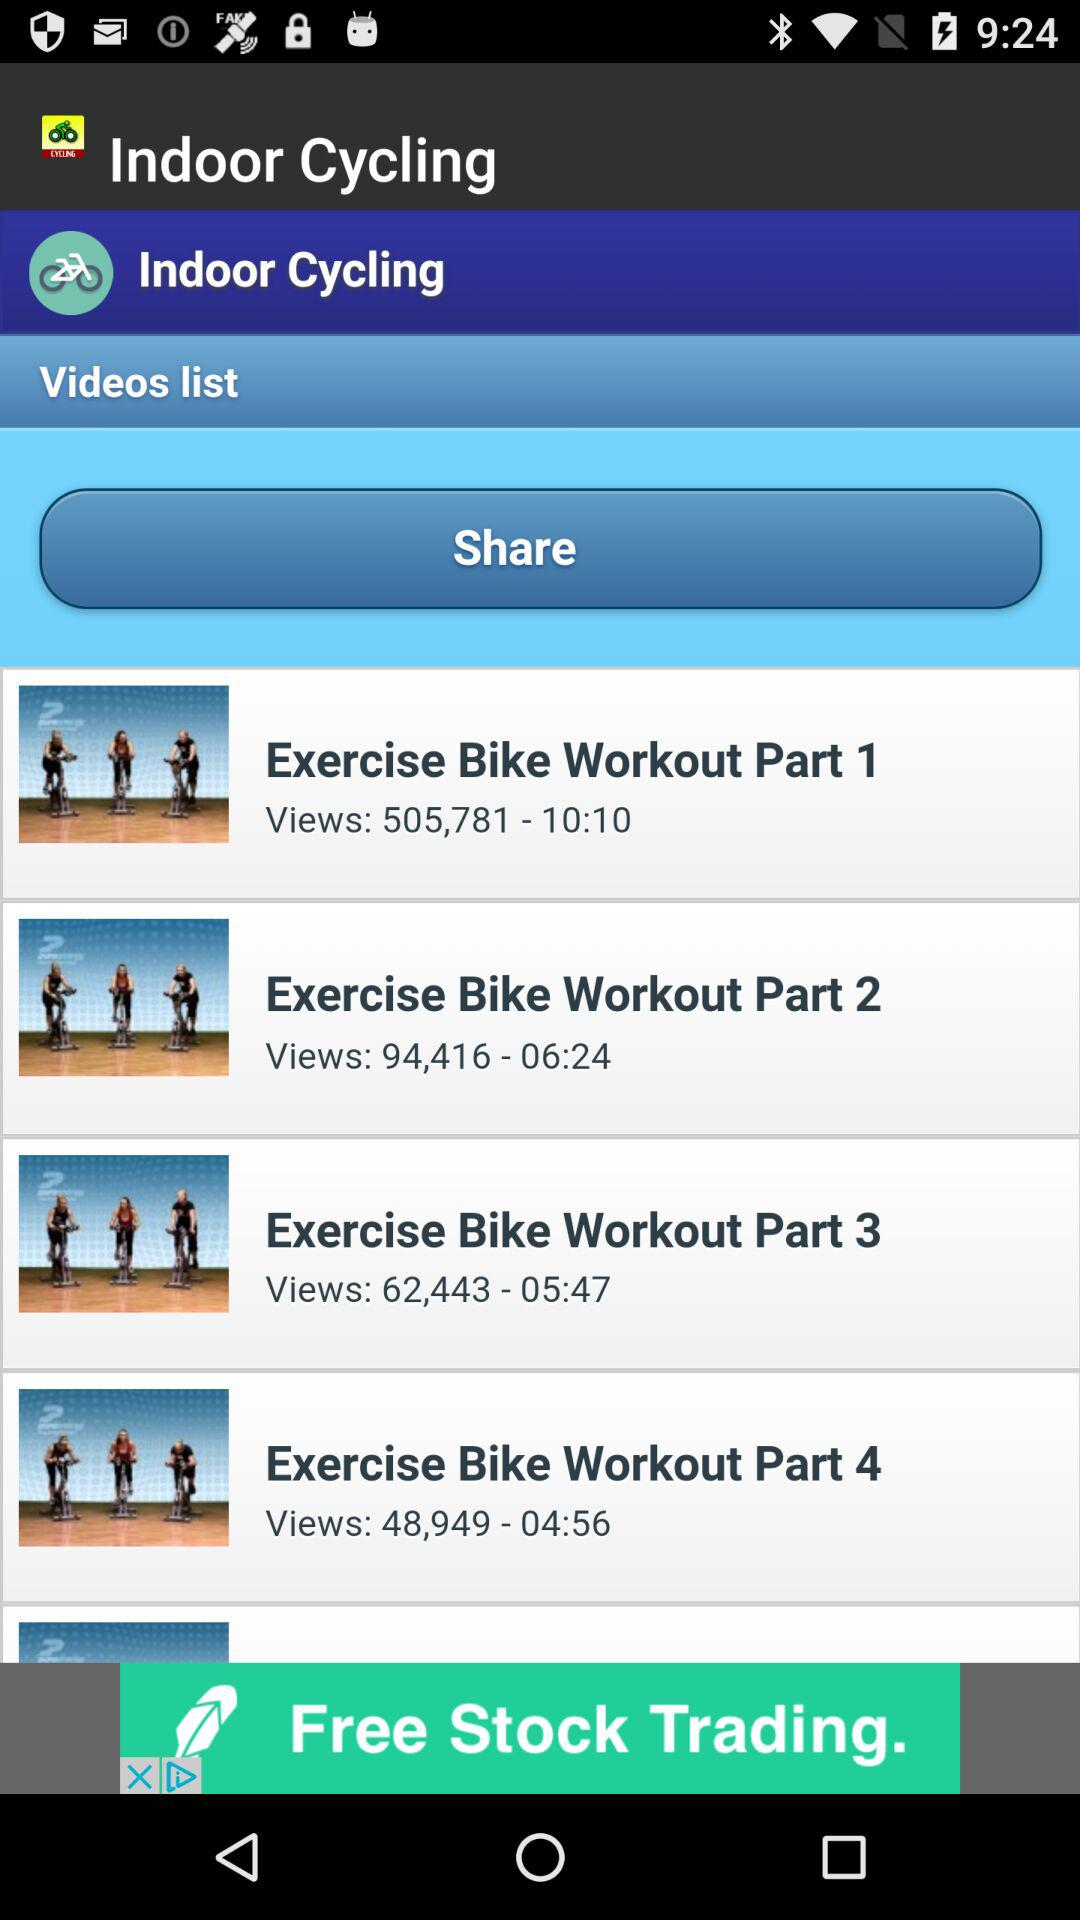How many views did the video "Exercise Bike Workout Part 3" get? The video "Exercise Bike Workout Part 3" got 62,443 views. 